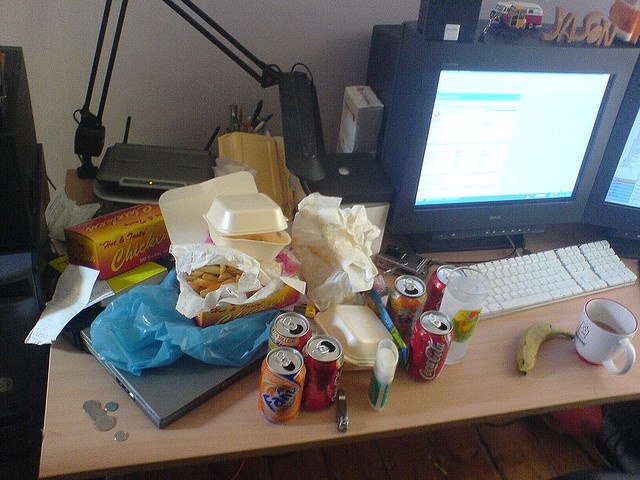Describe the objects in this image and their specific colors. I can see tv in gray, white, blue, and navy tones, keyboard in gray, lightgray, and darkgray tones, tv in gray, blue, lightblue, and navy tones, laptop in gray, black, blue, and navy tones, and cup in gray and darkgray tones in this image. 